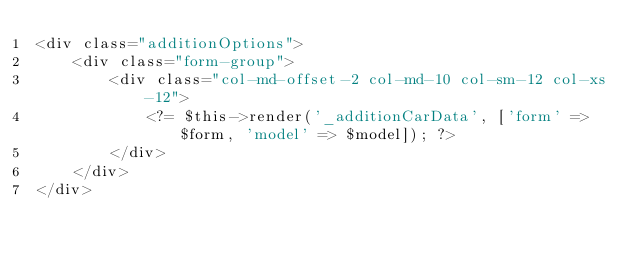Convert code to text. <code><loc_0><loc_0><loc_500><loc_500><_PHP_><div class="additionOptions">
    <div class="form-group">
        <div class="col-md-offset-2 col-md-10 col-sm-12 col-xs-12">
            <?= $this->render('_additionCarData', ['form' => $form, 'model' => $model]); ?>
        </div>
    </div>
</div></code> 